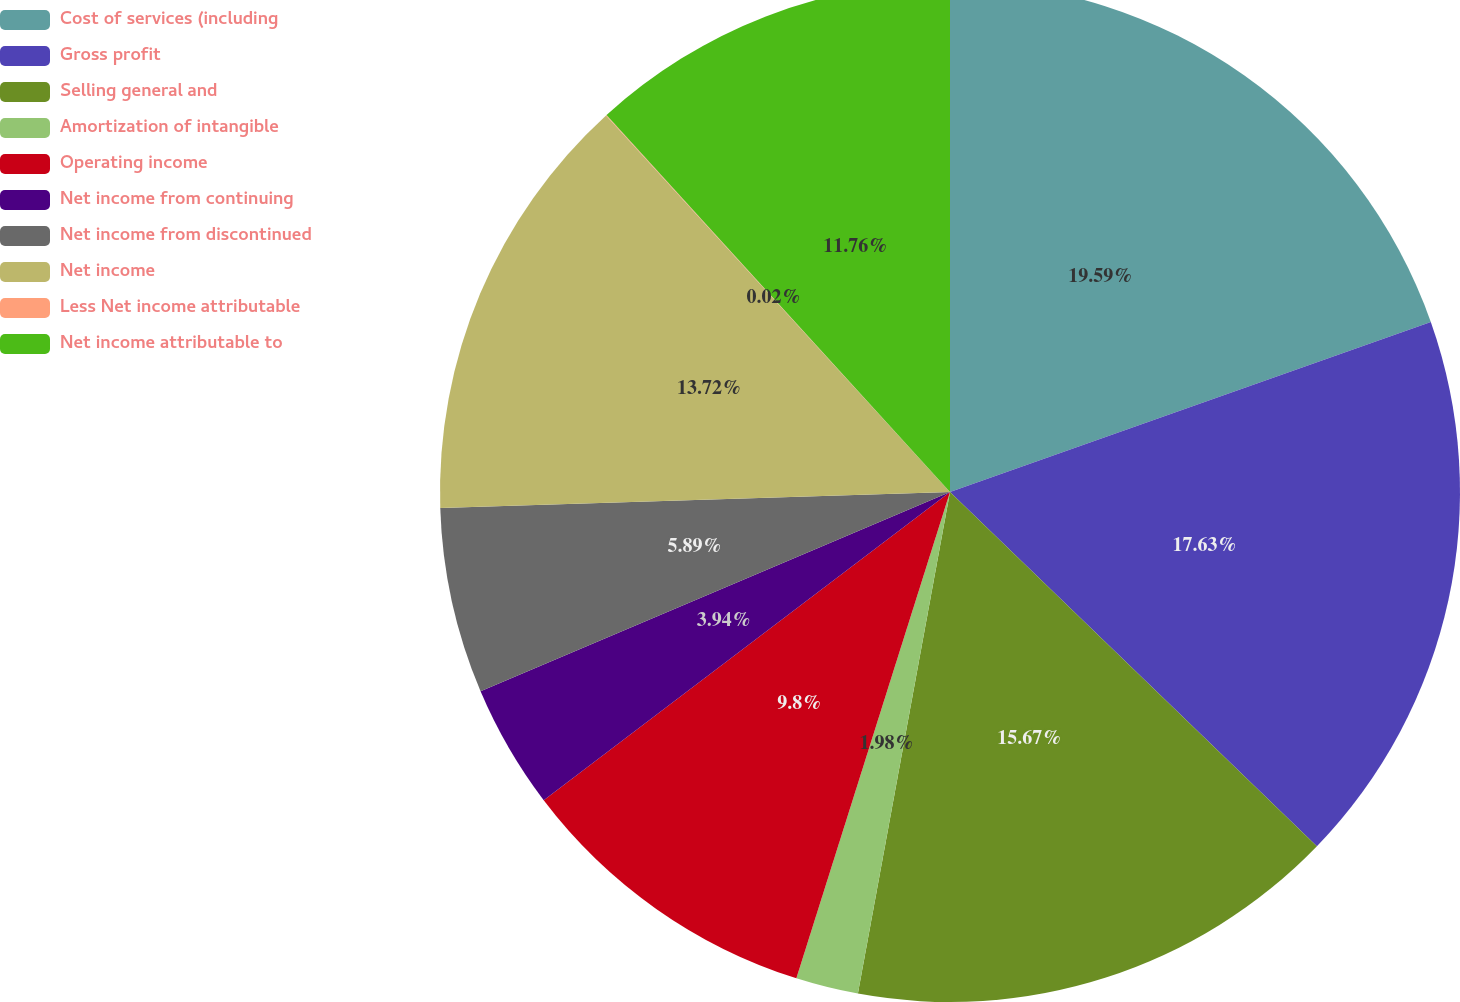<chart> <loc_0><loc_0><loc_500><loc_500><pie_chart><fcel>Cost of services (including<fcel>Gross profit<fcel>Selling general and<fcel>Amortization of intangible<fcel>Operating income<fcel>Net income from continuing<fcel>Net income from discontinued<fcel>Net income<fcel>Less Net income attributable<fcel>Net income attributable to<nl><fcel>19.59%<fcel>17.63%<fcel>15.67%<fcel>1.98%<fcel>9.8%<fcel>3.94%<fcel>5.89%<fcel>13.72%<fcel>0.02%<fcel>11.76%<nl></chart> 